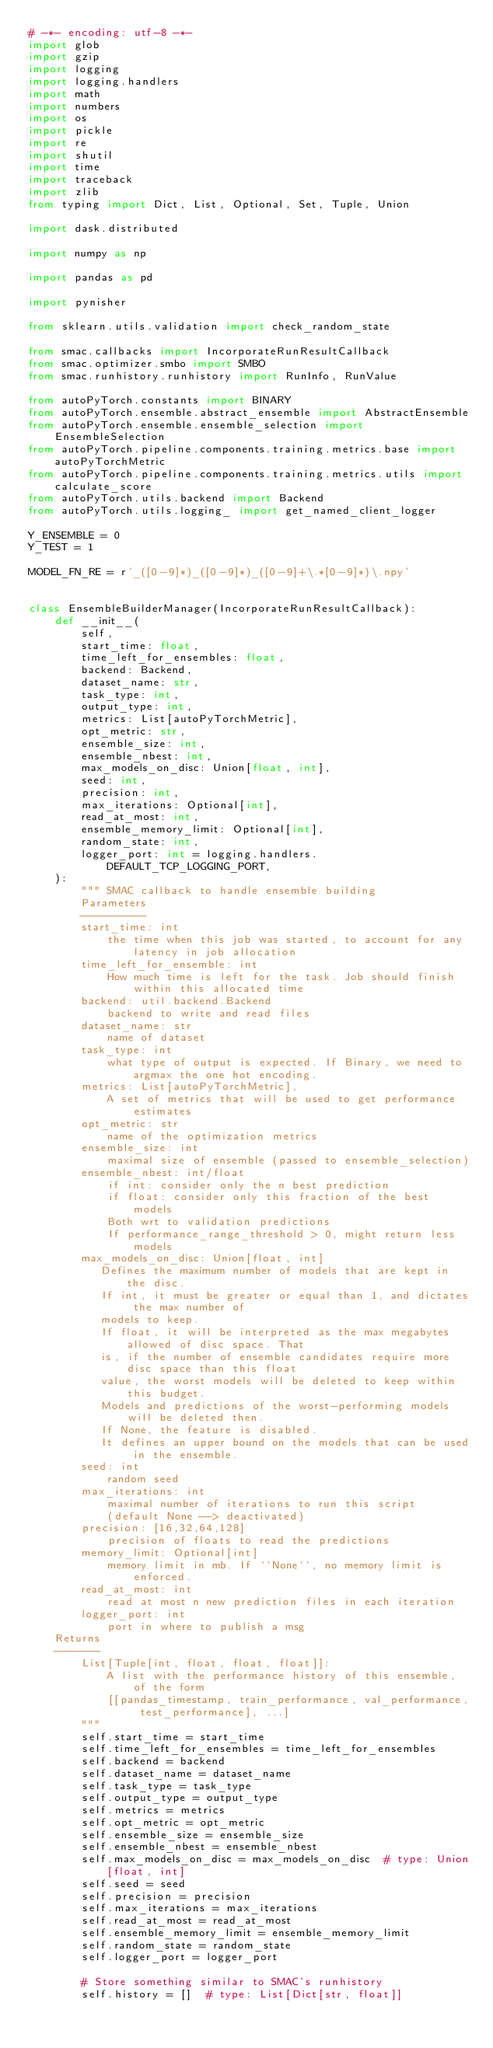Convert code to text. <code><loc_0><loc_0><loc_500><loc_500><_Python_># -*- encoding: utf-8 -*-
import glob
import gzip
import logging
import logging.handlers
import math
import numbers
import os
import pickle
import re
import shutil
import time
import traceback
import zlib
from typing import Dict, List, Optional, Set, Tuple, Union

import dask.distributed

import numpy as np

import pandas as pd

import pynisher

from sklearn.utils.validation import check_random_state

from smac.callbacks import IncorporateRunResultCallback
from smac.optimizer.smbo import SMBO
from smac.runhistory.runhistory import RunInfo, RunValue

from autoPyTorch.constants import BINARY
from autoPyTorch.ensemble.abstract_ensemble import AbstractEnsemble
from autoPyTorch.ensemble.ensemble_selection import EnsembleSelection
from autoPyTorch.pipeline.components.training.metrics.base import autoPyTorchMetric
from autoPyTorch.pipeline.components.training.metrics.utils import calculate_score
from autoPyTorch.utils.backend import Backend
from autoPyTorch.utils.logging_ import get_named_client_logger

Y_ENSEMBLE = 0
Y_TEST = 1

MODEL_FN_RE = r'_([0-9]*)_([0-9]*)_([0-9]+\.*[0-9]*)\.npy'


class EnsembleBuilderManager(IncorporateRunResultCallback):
    def __init__(
        self,
        start_time: float,
        time_left_for_ensembles: float,
        backend: Backend,
        dataset_name: str,
        task_type: int,
        output_type: int,
        metrics: List[autoPyTorchMetric],
        opt_metric: str,
        ensemble_size: int,
        ensemble_nbest: int,
        max_models_on_disc: Union[float, int],
        seed: int,
        precision: int,
        max_iterations: Optional[int],
        read_at_most: int,
        ensemble_memory_limit: Optional[int],
        random_state: int,
        logger_port: int = logging.handlers.DEFAULT_TCP_LOGGING_PORT,
    ):
        """ SMAC callback to handle ensemble building
        Parameters
        ----------
        start_time: int
            the time when this job was started, to account for any latency in job allocation
        time_left_for_ensemble: int
            How much time is left for the task. Job should finish within this allocated time
        backend: util.backend.Backend
            backend to write and read files
        dataset_name: str
            name of dataset
        task_type: int
            what type of output is expected. If Binary, we need to argmax the one hot encoding.
        metrics: List[autoPyTorchMetric],
            A set of metrics that will be used to get performance estimates
        opt_metric: str
            name of the optimization metrics
        ensemble_size: int
            maximal size of ensemble (passed to ensemble_selection)
        ensemble_nbest: int/float
            if int: consider only the n best prediction
            if float: consider only this fraction of the best models
            Both wrt to validation predictions
            If performance_range_threshold > 0, might return less models
        max_models_on_disc: Union[float, int]
           Defines the maximum number of models that are kept in the disc.
           If int, it must be greater or equal than 1, and dictates the max number of
           models to keep.
           If float, it will be interpreted as the max megabytes allowed of disc space. That
           is, if the number of ensemble candidates require more disc space than this float
           value, the worst models will be deleted to keep within this budget.
           Models and predictions of the worst-performing models will be deleted then.
           If None, the feature is disabled.
           It defines an upper bound on the models that can be used in the ensemble.
        seed: int
            random seed
        max_iterations: int
            maximal number of iterations to run this script
            (default None --> deactivated)
        precision: [16,32,64,128]
            precision of floats to read the predictions
        memory_limit: Optional[int]
            memory limit in mb. If ``None``, no memory limit is enforced.
        read_at_most: int
            read at most n new prediction files in each iteration
        logger_port: int
            port in where to publish a msg
    Returns
    -------
        List[Tuple[int, float, float, float]]:
            A list with the performance history of this ensemble, of the form
            [[pandas_timestamp, train_performance, val_performance, test_performance], ...]
        """
        self.start_time = start_time
        self.time_left_for_ensembles = time_left_for_ensembles
        self.backend = backend
        self.dataset_name = dataset_name
        self.task_type = task_type
        self.output_type = output_type
        self.metrics = metrics
        self.opt_metric = opt_metric
        self.ensemble_size = ensemble_size
        self.ensemble_nbest = ensemble_nbest
        self.max_models_on_disc = max_models_on_disc  # type: Union[float, int]
        self.seed = seed
        self.precision = precision
        self.max_iterations = max_iterations
        self.read_at_most = read_at_most
        self.ensemble_memory_limit = ensemble_memory_limit
        self.random_state = random_state
        self.logger_port = logger_port

        # Store something similar to SMAC's runhistory
        self.history = []  # type: List[Dict[str, float]]
</code> 